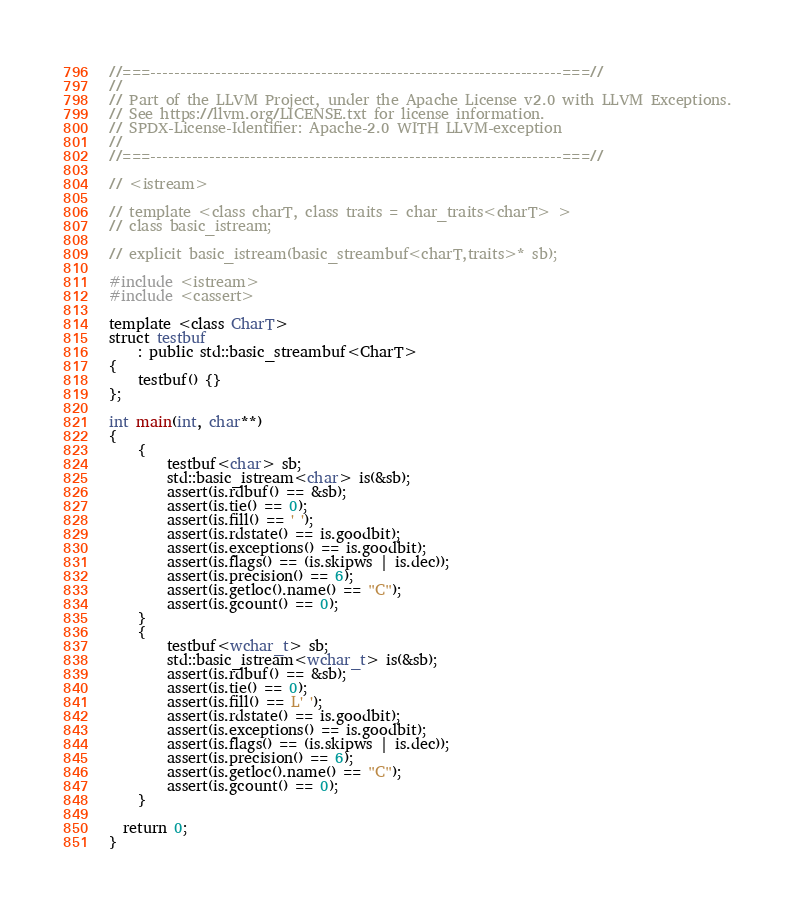Convert code to text. <code><loc_0><loc_0><loc_500><loc_500><_C++_>//===----------------------------------------------------------------------===//
//
// Part of the LLVM Project, under the Apache License v2.0 with LLVM Exceptions.
// See https://llvm.org/LICENSE.txt for license information.
// SPDX-License-Identifier: Apache-2.0 WITH LLVM-exception
//
//===----------------------------------------------------------------------===//

// <istream>

// template <class charT, class traits = char_traits<charT> >
// class basic_istream;

// explicit basic_istream(basic_streambuf<charT,traits>* sb);

#include <istream>
#include <cassert>

template <class CharT>
struct testbuf
    : public std::basic_streambuf<CharT>
{
    testbuf() {}
};

int main(int, char**)
{
    {
        testbuf<char> sb;
        std::basic_istream<char> is(&sb);
        assert(is.rdbuf() == &sb);
        assert(is.tie() == 0);
        assert(is.fill() == ' ');
        assert(is.rdstate() == is.goodbit);
        assert(is.exceptions() == is.goodbit);
        assert(is.flags() == (is.skipws | is.dec));
        assert(is.precision() == 6);
        assert(is.getloc().name() == "C");
        assert(is.gcount() == 0);
    }
    {
        testbuf<wchar_t> sb;
        std::basic_istream<wchar_t> is(&sb);
        assert(is.rdbuf() == &sb);
        assert(is.tie() == 0);
        assert(is.fill() == L' ');
        assert(is.rdstate() == is.goodbit);
        assert(is.exceptions() == is.goodbit);
        assert(is.flags() == (is.skipws | is.dec));
        assert(is.precision() == 6);
        assert(is.getloc().name() == "C");
        assert(is.gcount() == 0);
    }

  return 0;
}
</code> 